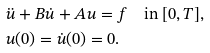Convert formula to latex. <formula><loc_0><loc_0><loc_500><loc_500>& \ddot { u } + B \dot { u } + A u = f \quad \text {in } [ 0 , T ] , \\ & u ( 0 ) = \dot { u } ( 0 ) = 0 .</formula> 